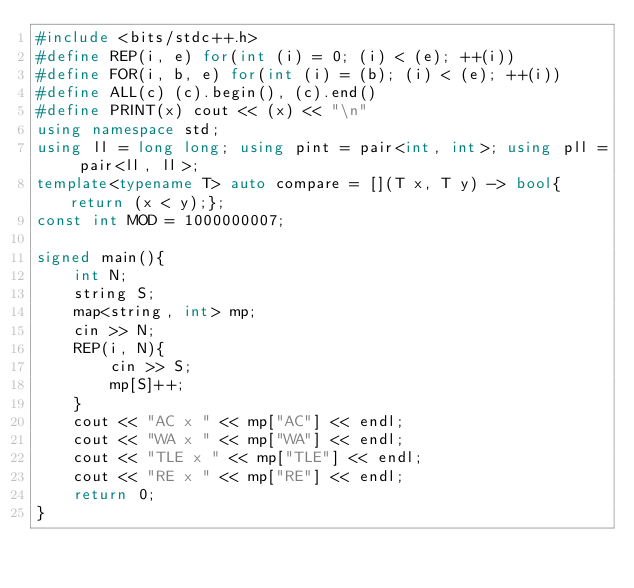<code> <loc_0><loc_0><loc_500><loc_500><_C++_>#include <bits/stdc++.h>
#define REP(i, e) for(int (i) = 0; (i) < (e); ++(i))
#define FOR(i, b, e) for(int (i) = (b); (i) < (e); ++(i))
#define ALL(c) (c).begin(), (c).end()
#define PRINT(x) cout << (x) << "\n"
using namespace std;
using ll = long long; using pint = pair<int, int>; using pll = pair<ll, ll>;
template<typename T> auto compare = [](T x, T y) -> bool{return (x < y);};
const int MOD = 1000000007;

signed main(){
    int N;
    string S;
    map<string, int> mp;
    cin >> N;
    REP(i, N){
        cin >> S;
        mp[S]++;
    }
    cout << "AC x " << mp["AC"] << endl;
    cout << "WA x " << mp["WA"] << endl;
    cout << "TLE x " << mp["TLE"] << endl;
    cout << "RE x " << mp["RE"] << endl;
    return 0;
}</code> 